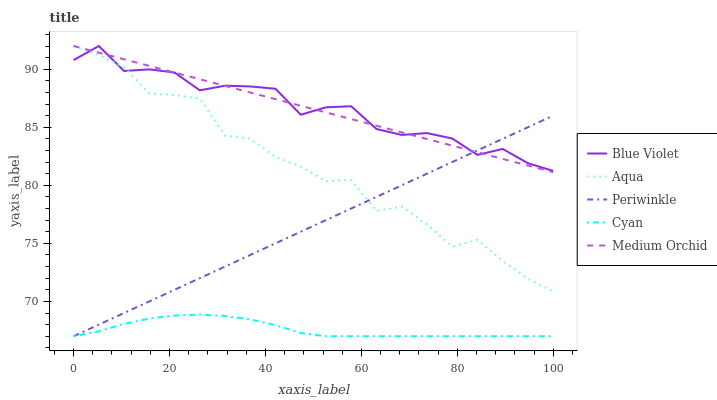Does Medium Orchid have the minimum area under the curve?
Answer yes or no. No. Does Medium Orchid have the maximum area under the curve?
Answer yes or no. No. Is Aqua the smoothest?
Answer yes or no. No. Is Medium Orchid the roughest?
Answer yes or no. No. Does Medium Orchid have the lowest value?
Answer yes or no. No. Does Cyan have the highest value?
Answer yes or no. No. Is Cyan less than Blue Violet?
Answer yes or no. Yes. Is Aqua greater than Cyan?
Answer yes or no. Yes. Does Cyan intersect Blue Violet?
Answer yes or no. No. 